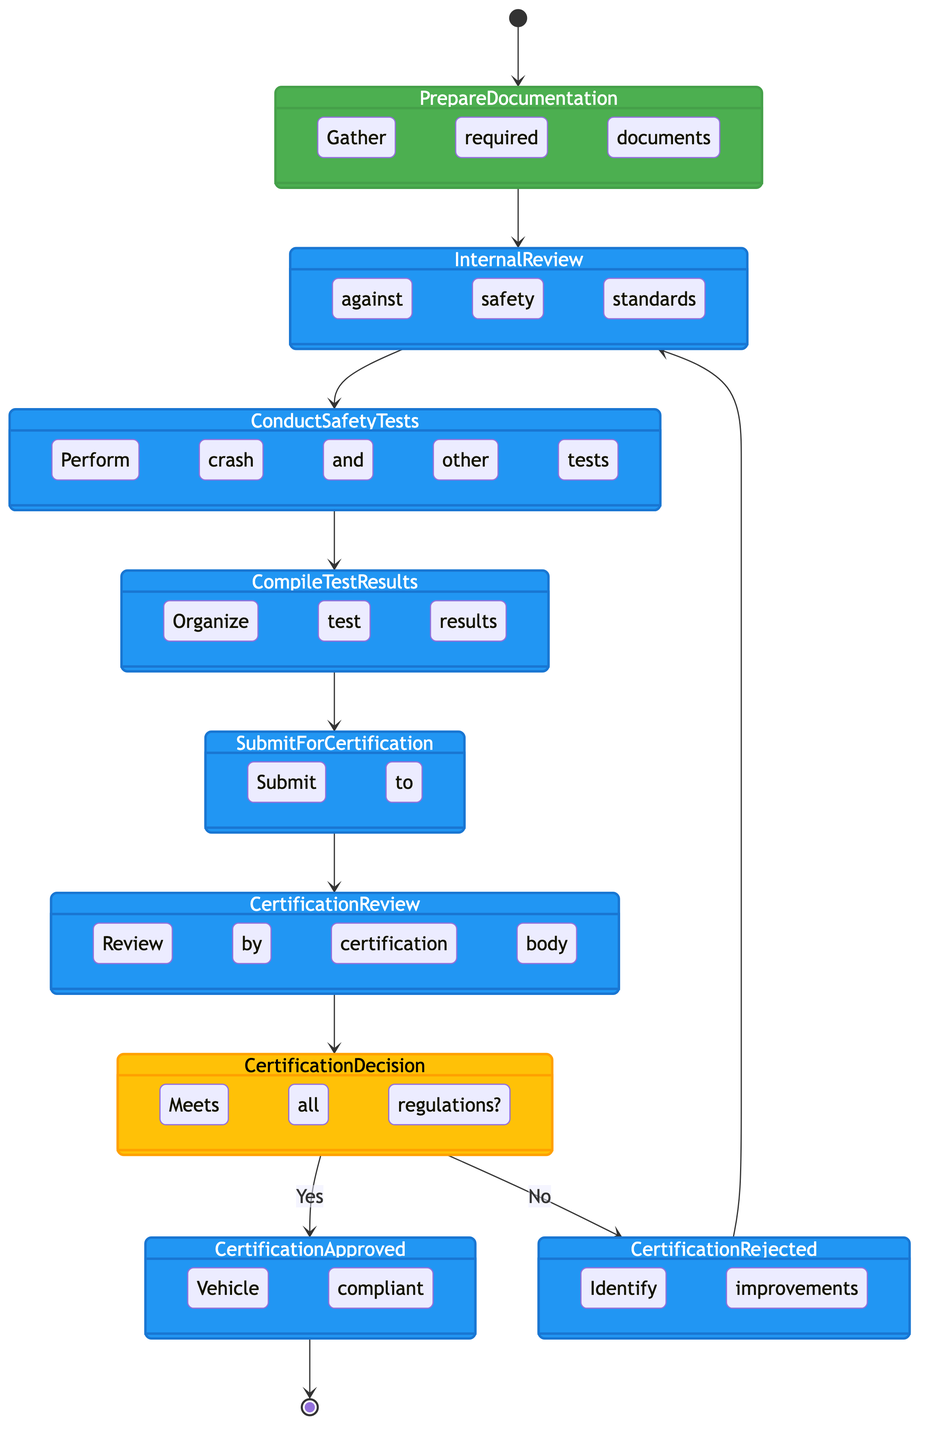What is the first activity in the diagram? The diagram begins with the "Prepare Documentation" activity, indicated as the first step following the start node.
Answer: Prepare Documentation How many activities are there in total? The diagram includes five distinct activities: "Prepare Documentation," "Internal Review," "Conduct Safety Tests," "Compile Test Results," and "Submit for Certification."
Answer: 5 What is the condition for the "Certification Decision" to lead to "Certification Approved"? The "Certification Decision" leads to "Certification Approved" if the condition is "yes," which is explicitly stated in the transition from the decision node to the approval node.
Answer: yes What does the "Certification Rejected" activity indicate? The "Certification Rejected" activity indicates that the vehicle does not meet safety regulations and involves identifying areas for improvement and making necessary adjustments, as described in the activity node.
Answer: Identify improvements What happens after "Certification Approved"? Once "Certification Approved" is reached, the flow proceeds to the end node, indicating the process concludes after the vehicle is certified compliant with safety regulations.
Answer: End What is the purpose of the "Internal Review" activity? The purpose of the "Internal Review" activity is to conduct a review of the vehicle design against national and international safety standards, ensuring compliance before safety tests are conducted.
Answer: Review against safety standards If the vehicle is rejected, which activity does the process revert to? If the vehicle is rejected during the "Certification Decision," the process reverts back to the "Internal Review" activity to allow for improvements to be made before re-evaluation.
Answer: Internal Review How many decisions are present in the diagram? There is one decision point in the diagram, represented by "Certification Decision," where the determination of compliance with safety regulations is made.
Answer: 1 What is the last step if the certification is approved? The last step of the process if the certification is approved is reaching the end node, signifying the completion of the certification process.
Answer: End 